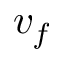<formula> <loc_0><loc_0><loc_500><loc_500>v _ { f }</formula> 